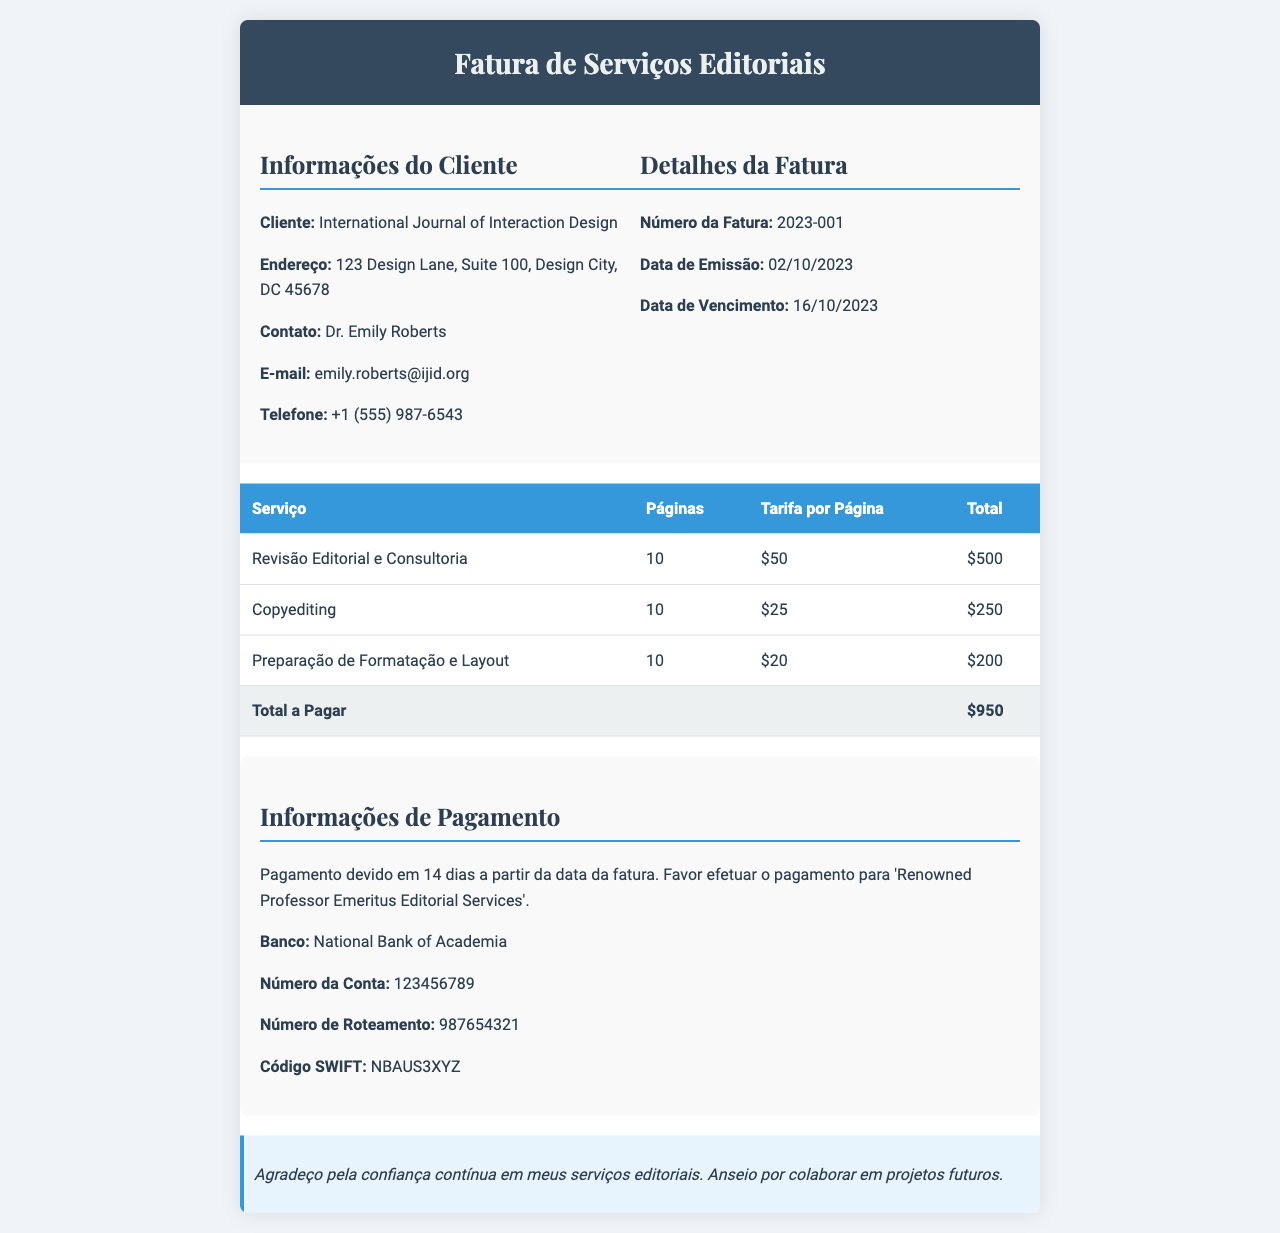Qual é o nome do cliente? O nome do cliente é informado na seção de informações do cliente.
Answer: International Journal of Interaction Design Qual é o número da fatura? O número da fatura é fornecido na seção de detalhes da fatura.
Answer: 2023-001 Qual é a data de vencimento da fatura? A data de vencimento é mencionada na seção de detalhes da fatura.
Answer: 16/10/2023 Quantas páginas foram revisadas no serviço de revisão editorial? O número de páginas está listado na tabela sob o serviço de revisão editorial.
Answer: 10 Qual é o total a pagar pela fatura? O total a pagar é apresentado na linha total da tabela.
Answer: $950 Qual é o valor da tarifa por página para copyediting? A tarifa por página para copyediting é indicada na tabela ao lado do serviço correspondente.
Answer: $25 Qual o nome do banco para o pagamento? O nome do banco para o pagamento está listado na seção de informações de pagamento.
Answer: National Bank of Academia Quantos dias após a data da fatura o pagamento é devido? O prazo para pagamento é mencionado na seção de informações de pagamento.
Answer: 14 dias Quantas páginas foram editadas no total? O total de páginas para todos os serviços é a soma das páginas listadas na tabela.
Answer: 30 